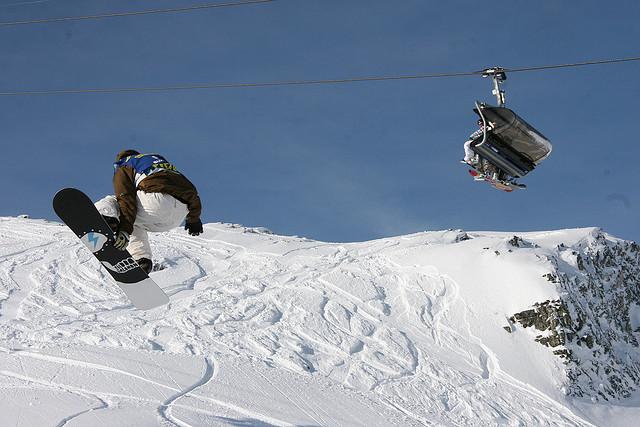Is the ski lift occupied?
Quick response, please. Yes. How many people are in the chair lift?
Give a very brief answer. 3. What is that left person doing?
Short answer required. Snowboarding. 